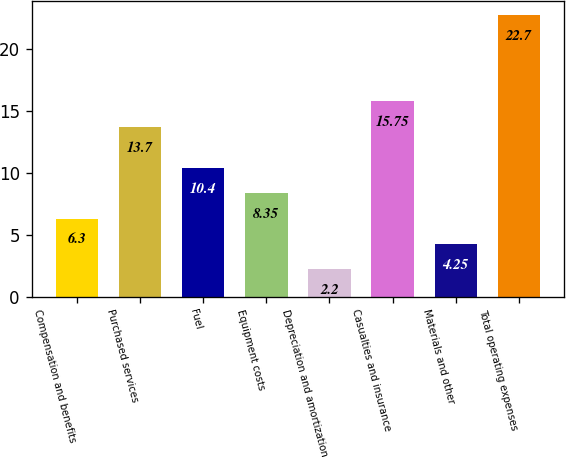<chart> <loc_0><loc_0><loc_500><loc_500><bar_chart><fcel>Compensation and benefits<fcel>Purchased services<fcel>Fuel<fcel>Equipment costs<fcel>Depreciation and amortization<fcel>Casualties and insurance<fcel>Materials and other<fcel>Total operating expenses<nl><fcel>6.3<fcel>13.7<fcel>10.4<fcel>8.35<fcel>2.2<fcel>15.75<fcel>4.25<fcel>22.7<nl></chart> 